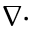Convert formula to latex. <formula><loc_0><loc_0><loc_500><loc_500>\nabla \cdot</formula> 